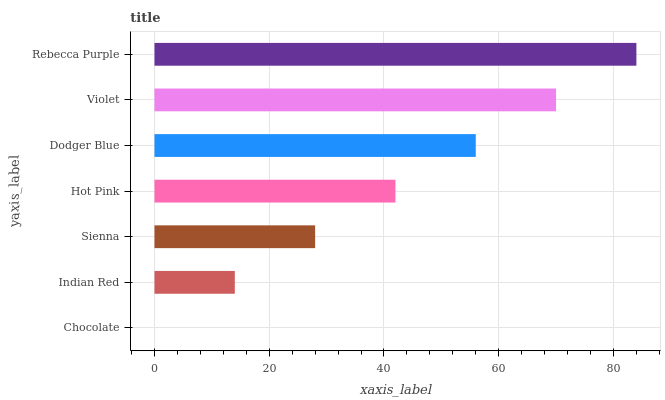Is Chocolate the minimum?
Answer yes or no. Yes. Is Rebecca Purple the maximum?
Answer yes or no. Yes. Is Indian Red the minimum?
Answer yes or no. No. Is Indian Red the maximum?
Answer yes or no. No. Is Indian Red greater than Chocolate?
Answer yes or no. Yes. Is Chocolate less than Indian Red?
Answer yes or no. Yes. Is Chocolate greater than Indian Red?
Answer yes or no. No. Is Indian Red less than Chocolate?
Answer yes or no. No. Is Hot Pink the high median?
Answer yes or no. Yes. Is Hot Pink the low median?
Answer yes or no. Yes. Is Rebecca Purple the high median?
Answer yes or no. No. Is Sienna the low median?
Answer yes or no. No. 